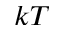<formula> <loc_0><loc_0><loc_500><loc_500>k T</formula> 